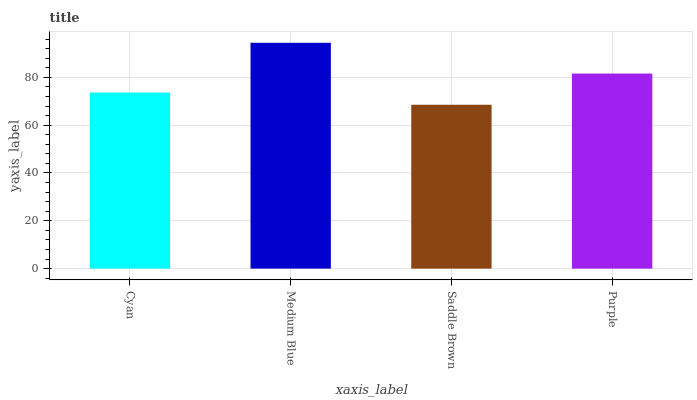Is Saddle Brown the minimum?
Answer yes or no. Yes. Is Medium Blue the maximum?
Answer yes or no. Yes. Is Medium Blue the minimum?
Answer yes or no. No. Is Saddle Brown the maximum?
Answer yes or no. No. Is Medium Blue greater than Saddle Brown?
Answer yes or no. Yes. Is Saddle Brown less than Medium Blue?
Answer yes or no. Yes. Is Saddle Brown greater than Medium Blue?
Answer yes or no. No. Is Medium Blue less than Saddle Brown?
Answer yes or no. No. Is Purple the high median?
Answer yes or no. Yes. Is Cyan the low median?
Answer yes or no. Yes. Is Cyan the high median?
Answer yes or no. No. Is Medium Blue the low median?
Answer yes or no. No. 